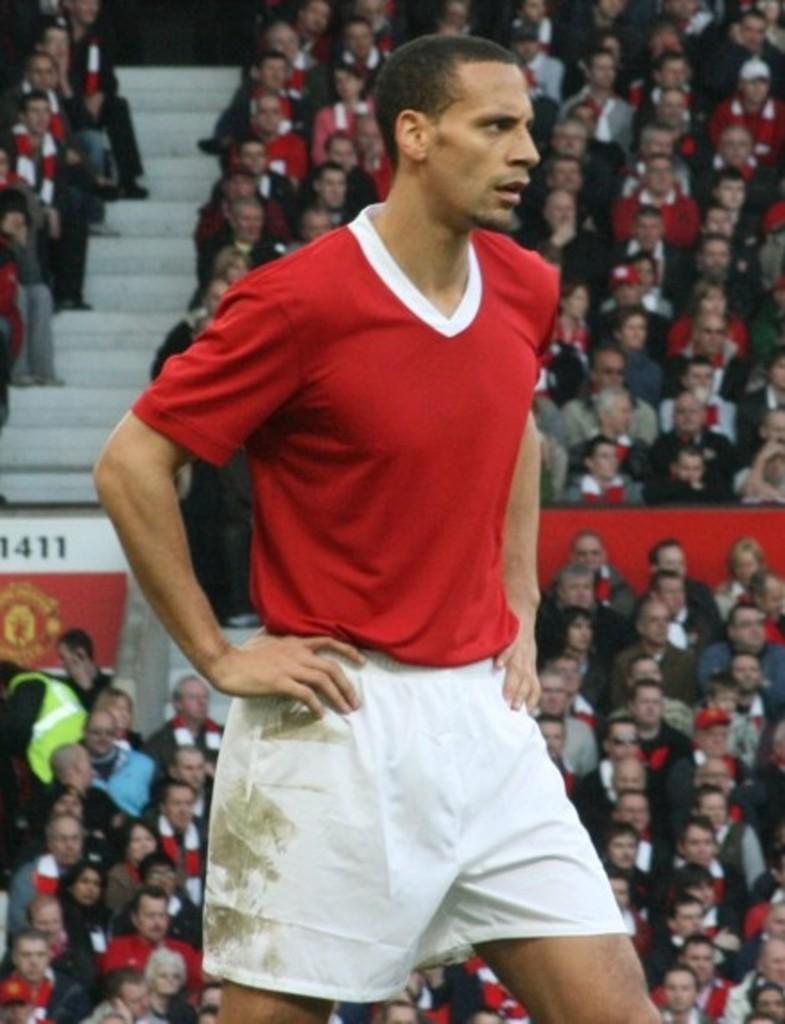Can you describe this image briefly? In this image I can see a person standing, wearing a red t shirt and white shorts. There are many people sitting at the back. 